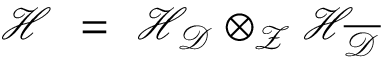<formula> <loc_0><loc_0><loc_500><loc_500>{ \mathcal { H } } \ = \ { \mathcal { H } } _ { \mathcal { D } } \otimes _ { \mathcal { Z } } { \mathcal { H } } _ { \overline { \mathcal { D } } }</formula> 